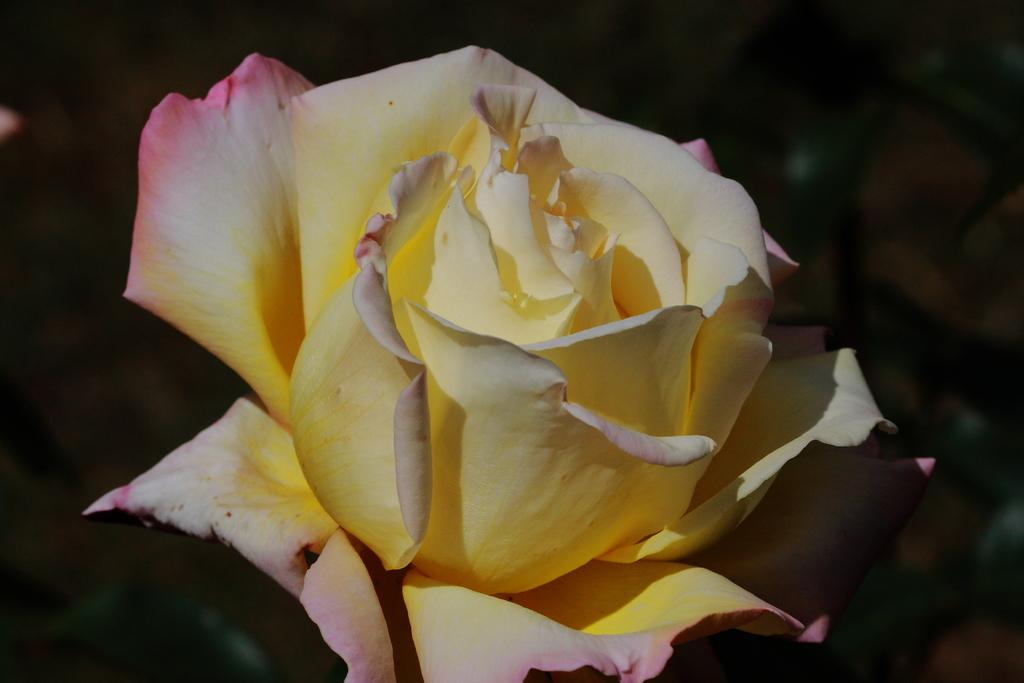What type of flower is in the image? There is a rose flower in the image. What other plant life is visible in the image? There are plants in the image. Can you tell if the image was taken during the day or night? The image may have been taken during the night. What type of wilderness can be seen in the background of the image? There is no wilderness visible in the image; it primarily features a rose flower and other plants. Is there a fire burning in the image? There is no fire present in the image. 